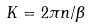<formula> <loc_0><loc_0><loc_500><loc_500>K = 2 \pi n / \beta</formula> 